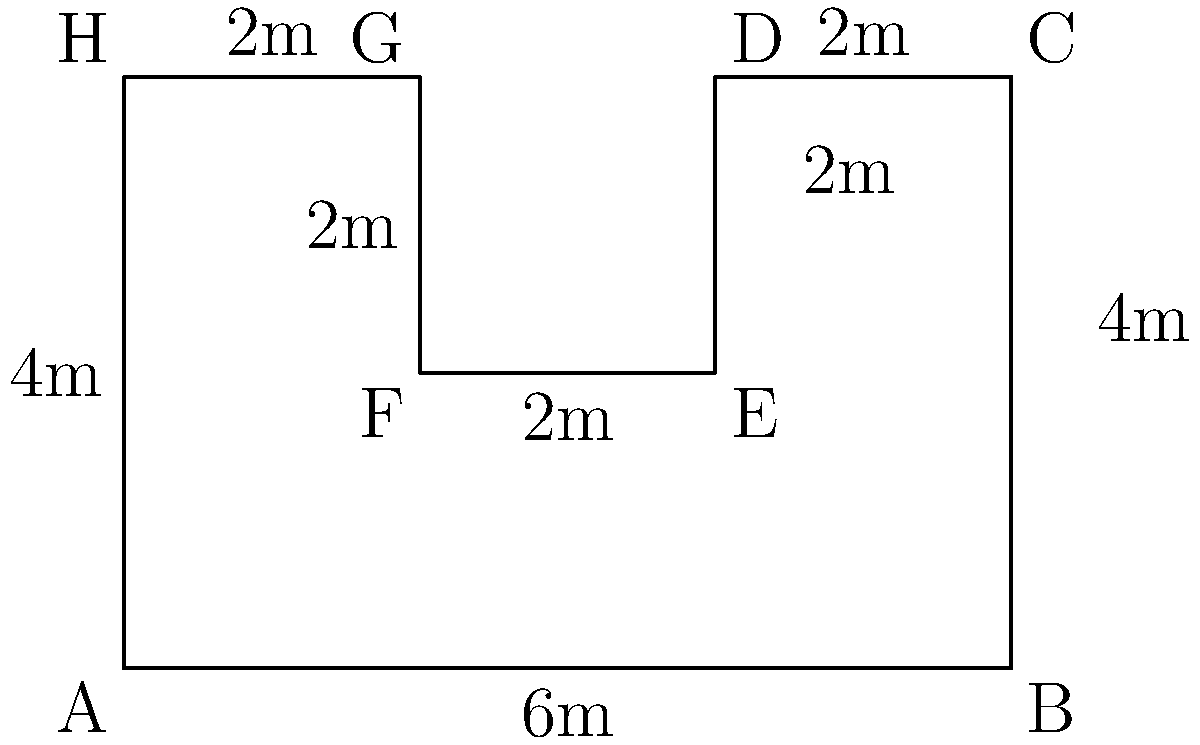As a civil engineer, you're tasked with calculating the area of an irregularly shaped building foundation. The foundation's shape is represented by the polygon ABCDEFGH in the diagram. Given the dimensions shown, what is the total area of the foundation in square meters? To solve this problem, we'll break down the irregular polygon into simpler shapes and calculate their areas separately. Then, we'll sum these areas to get the total area of the foundation.

Step 1: Divide the polygon into rectangles
We can divide the polygon into three rectangles:
1. Rectangle ABCH (main body)
2. Rectangle DEFG (left cutout)
3. Rectangle CDEF (right cutout)

Step 2: Calculate the areas of each rectangle
1. Area of ABCH = 6m × 4m = 24 m²
2. Area of DEFG = 2m × 2m = 4 m²
3. Area of CDEF = 2m × 2m = 4 m²

Step 3: Calculate the total area
Total Area = Area of ABCH - Area of DEFG - Area of CDEF
            = 24 m² - 4 m² - 4 m²
            = 16 m²

Therefore, the total area of the building foundation is 16 square meters.
Answer: 16 m² 